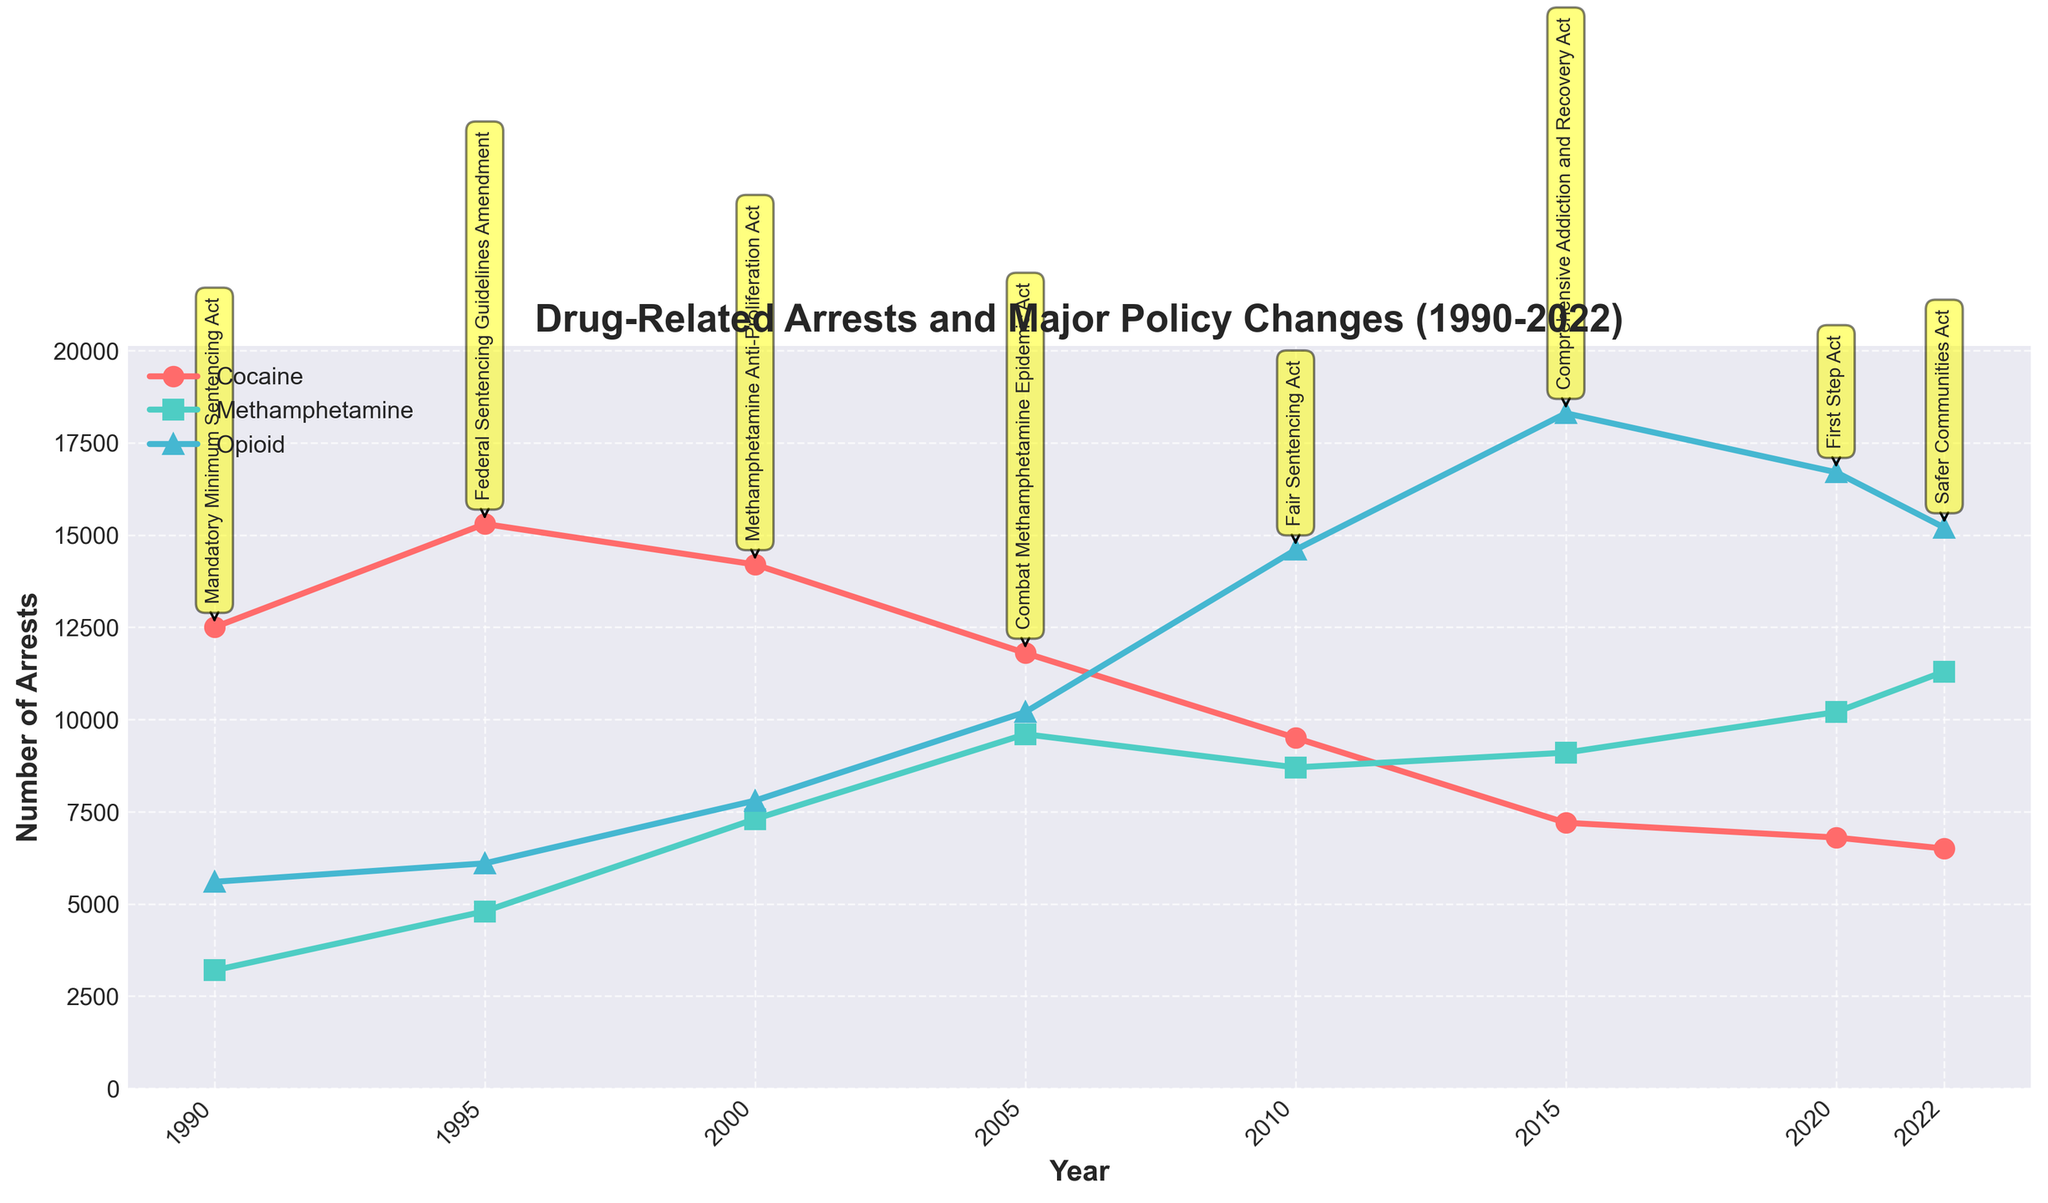What is the trend in cocaine-related arrests from 1990 to 2022? Cocaine-related arrests show a general decreasing trend from 1990 to 2022. They peaked in the mid-90s and have been steadily declining since then.
Answer: Decreasing How did methamphetamine-related arrests change between 2000 and 2005? Methamphetamine-related arrests increased from 7,300 in 2000 to 9,600 in 2005.
Answer: Increased Which year recorded the highest number of opioid-related arrests? The year 2015 recorded the highest number of opioid-related arrests with approximately 18,300 arrests.
Answer: 2015 Compare the methamphetamine-related arrests and cocaine-related arrests in 2020. Which is higher? In 2020, methamphetamine-related arrests (10,200) were higher than cocaine-related arrests (6,800).
Answer: Methamphetamine What is the difference in cocaine-related arrests between the years 1990 and 2022? Cocaine-related arrests in 1990 were 12,500 and in 2022 were 6,500. The difference is 12,500 - 6,500 = 6,000.
Answer: 6,000 Based on the figure, how did the Combat Methamphetamine Epidemic Act in 2005 appear to affect methamphetamine-related arrests? Before the Combat Methamphetamine Epidemic Act in 2005, arrests were rising. After the policy, they continued to rise but at a slower rate until 2010.
Answer: Continued to rise at a slower rate Which drug category saw the largest increase in arrests from 1990 to 2022? Opioid-related arrests saw the largest increase, from 5,600 in 1990 to 15,200 in 2022.
Answer: Opioid How do the cocaine-related arrests in 1995 compare to those in 2010? In 1995, cocaine-related arrests were 15,300, whereas in 2010, they were 9,500. 1995 had higher arrests compared to 2010.
Answer: 1995 had higher Identify the major policy change in the year 2000 and discuss its immediate apparent impact on methamphetamine-related arrests from 2000 to 2005. The Methamphetamine Anti-Proliferation Act was implemented in 2000. Following this, methamphetamine-related arrests increased from 7,300 in 2000 to 9,600 in 2005.
Answer: Methamphetamine Anti-Proliferation Act; arrests increased What visual attribute is used to represent different drug categories in the line chart? Different colors and markers represent the different drug categories: red circles for cocaine, green squares for methamphetamine, and blue triangles for opioids.
Answer: Colors and markers 